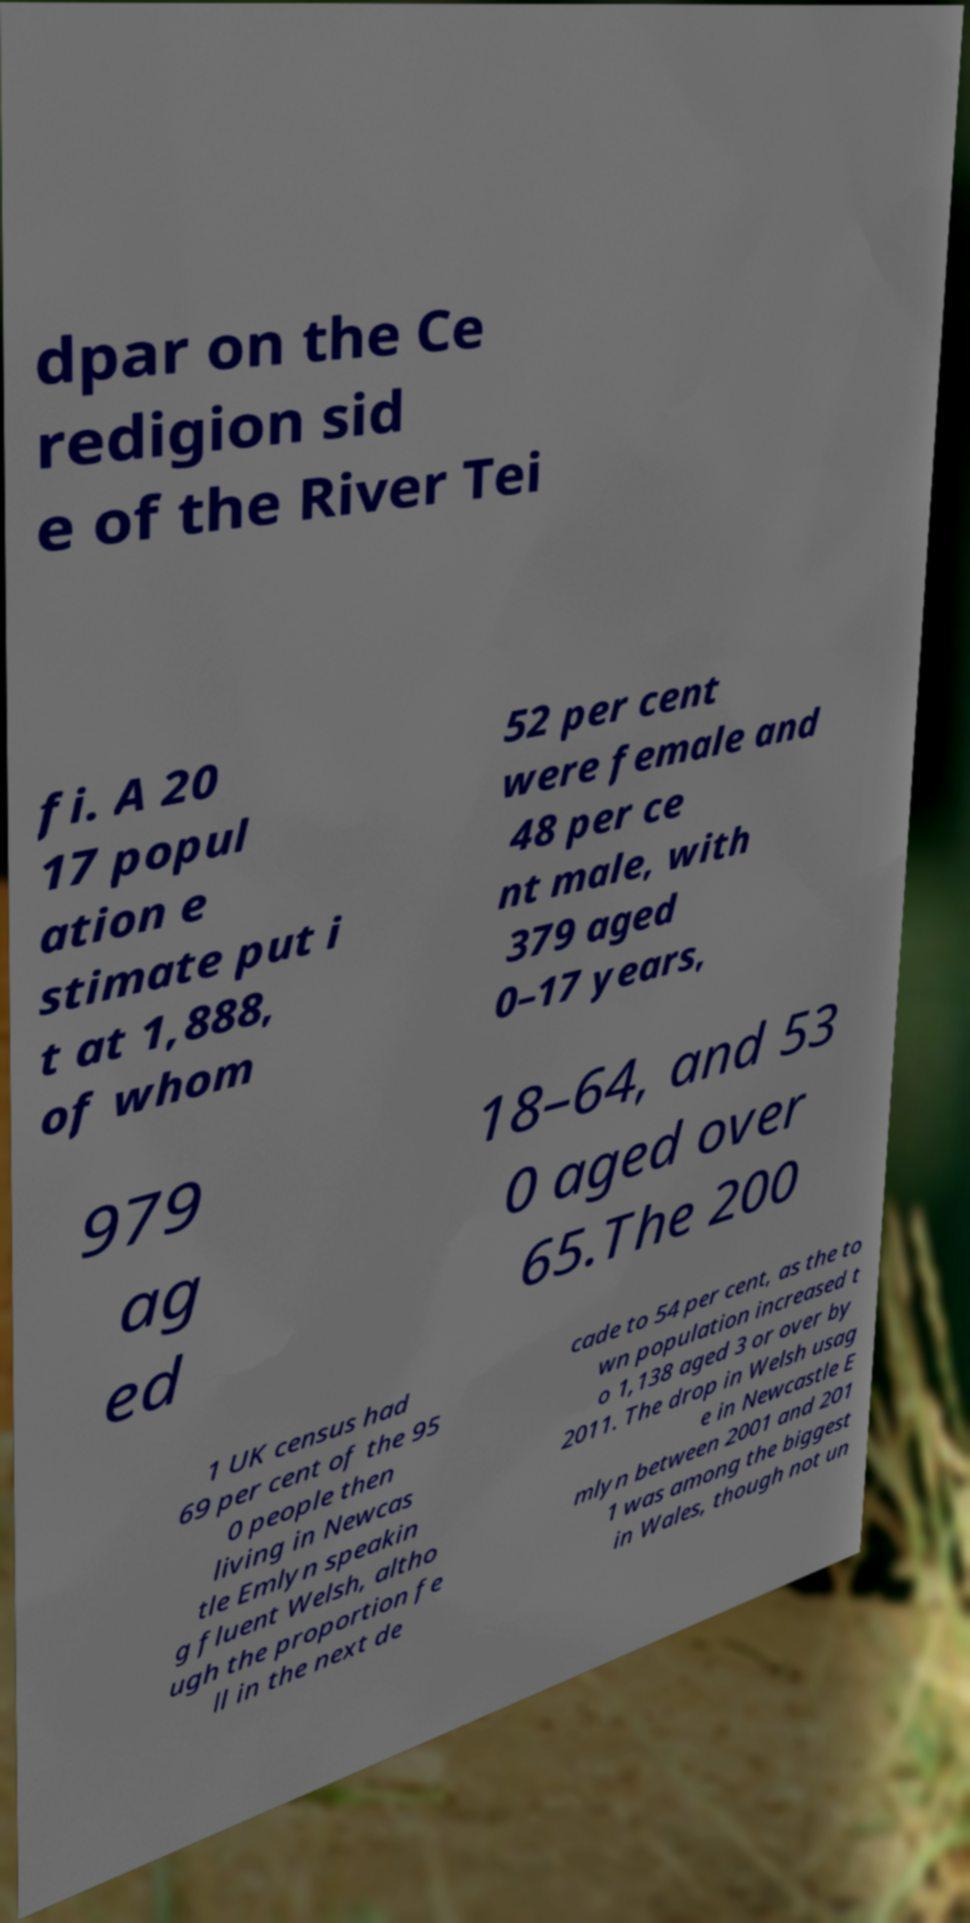Please read and relay the text visible in this image. What does it say? dpar on the Ce redigion sid e of the River Tei fi. A 20 17 popul ation e stimate put i t at 1,888, of whom 52 per cent were female and 48 per ce nt male, with 379 aged 0–17 years, 979 ag ed 18–64, and 53 0 aged over 65.The 200 1 UK census had 69 per cent of the 95 0 people then living in Newcas tle Emlyn speakin g fluent Welsh, altho ugh the proportion fe ll in the next de cade to 54 per cent, as the to wn population increased t o 1,138 aged 3 or over by 2011. The drop in Welsh usag e in Newcastle E mlyn between 2001 and 201 1 was among the biggest in Wales, though not un 